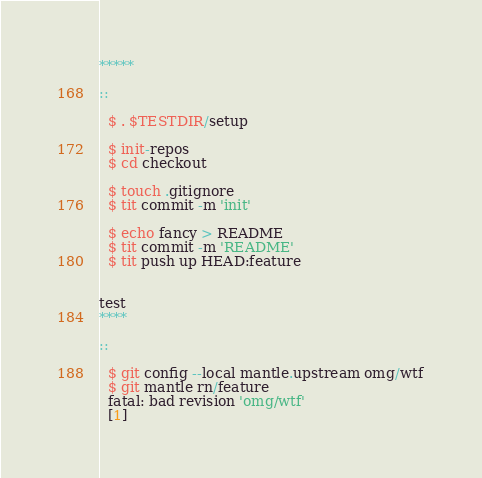Convert code to text. <code><loc_0><loc_0><loc_500><loc_500><_Perl_>*****

::

  $ . $TESTDIR/setup

  $ init-repos
  $ cd checkout

  $ touch .gitignore
  $ tit commit -m 'init'

  $ echo fancy > README
  $ tit commit -m 'README'
  $ tit push up HEAD:feature


test
****

::

  $ git config --local mantle.upstream omg/wtf
  $ git mantle rn/feature
  fatal: bad revision 'omg/wtf'
  [1]
</code> 